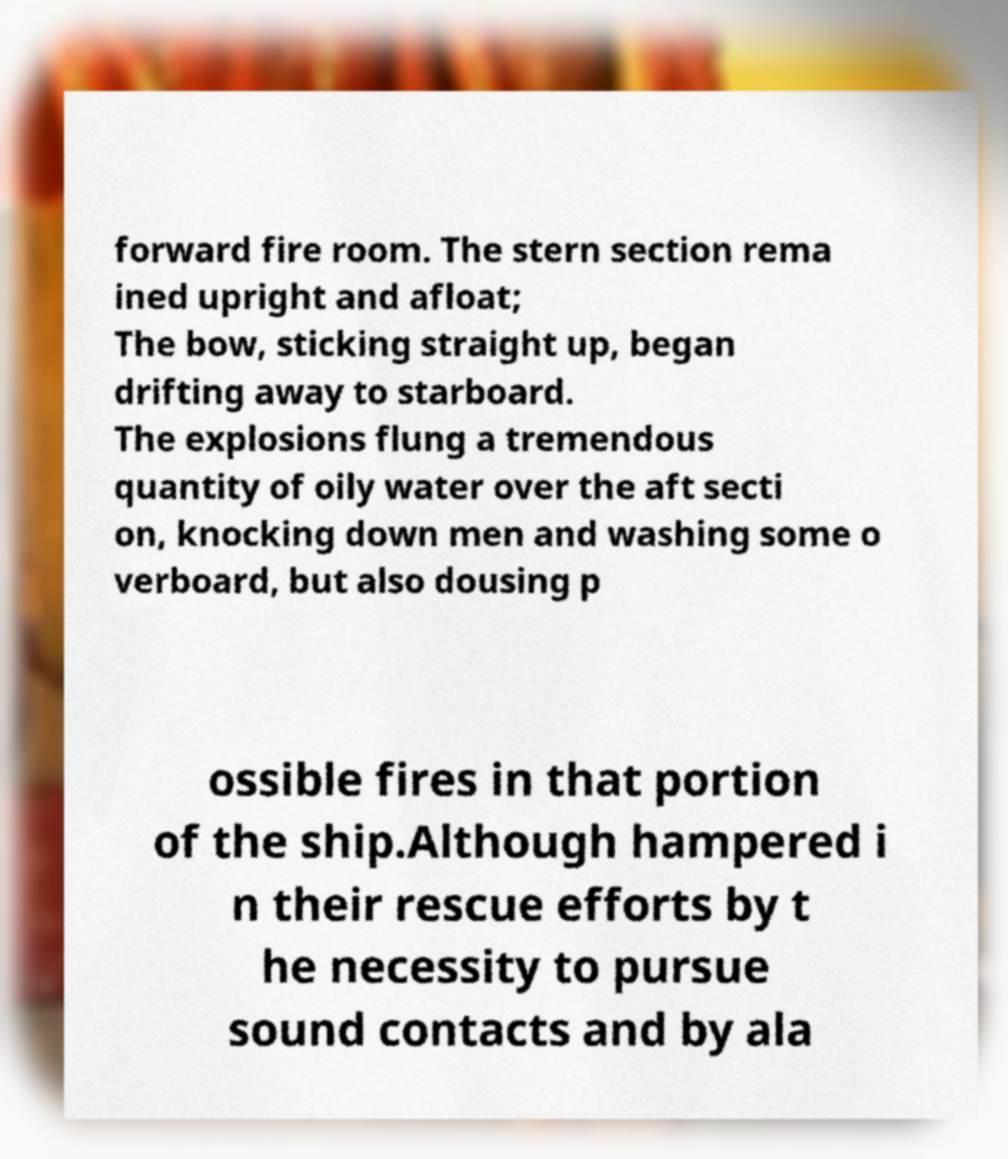I need the written content from this picture converted into text. Can you do that? forward fire room. The stern section rema ined upright and afloat; The bow, sticking straight up, began drifting away to starboard. The explosions flung a tremendous quantity of oily water over the aft secti on, knocking down men and washing some o verboard, but also dousing p ossible fires in that portion of the ship.Although hampered i n their rescue efforts by t he necessity to pursue sound contacts and by ala 